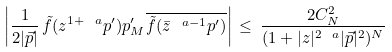Convert formula to latex. <formula><loc_0><loc_0><loc_500><loc_500>\left | \frac { 1 } { 2 | \vec { p } | } \, \tilde { f } ( z ^ { 1 + \ a } p ^ { \prime } ) p ^ { \prime } _ { M } \overline { \tilde { f } ( \bar { z } ^ { \ a - 1 } p ^ { \prime } ) } \right | \, \leq \, \frac { 2 C _ { N } ^ { 2 } } { ( 1 + | z | ^ { 2 \ a } | \vec { p } | ^ { 2 } ) ^ { N } }</formula> 